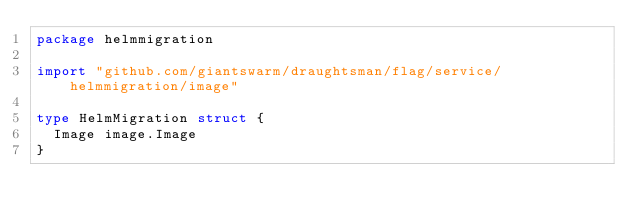<code> <loc_0><loc_0><loc_500><loc_500><_Go_>package helmmigration

import "github.com/giantswarm/draughtsman/flag/service/helmmigration/image"

type HelmMigration struct {
	Image image.Image
}
</code> 